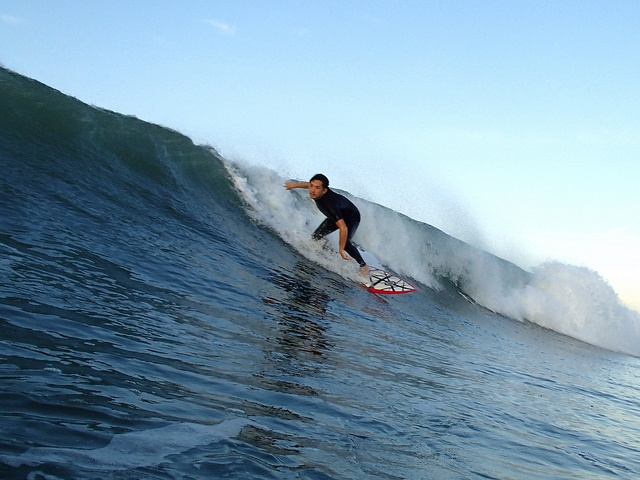Describe the objects in this image and their specific colors. I can see people in lightblue, black, brown, and maroon tones and surfboard in lightblue, darkgray, gray, black, and brown tones in this image. 